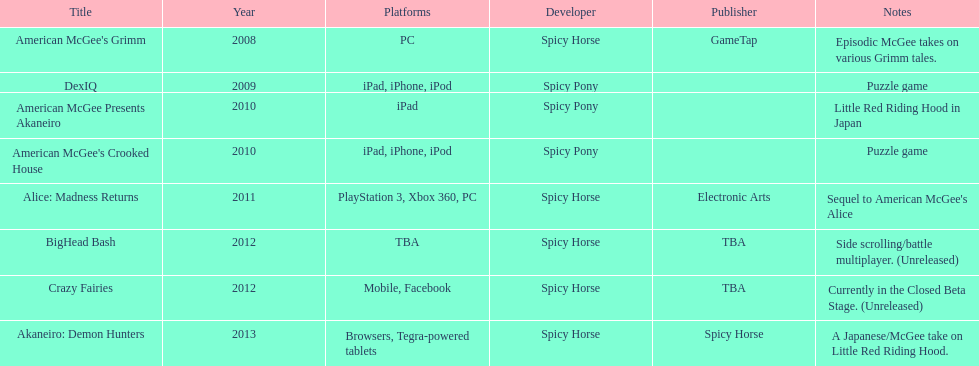Can you parse all the data within this table? {'header': ['Title', 'Year', 'Platforms', 'Developer', 'Publisher', 'Notes'], 'rows': [["American McGee's Grimm", '2008', 'PC', 'Spicy Horse', 'GameTap', 'Episodic McGee takes on various Grimm tales.'], ['DexIQ', '2009', 'iPad, iPhone, iPod', 'Spicy Pony', '', 'Puzzle game'], ['American McGee Presents Akaneiro', '2010', 'iPad', 'Spicy Pony', '', 'Little Red Riding Hood in Japan'], ["American McGee's Crooked House", '2010', 'iPad, iPhone, iPod', 'Spicy Pony', '', 'Puzzle game'], ['Alice: Madness Returns', '2011', 'PlayStation 3, Xbox 360, PC', 'Spicy Horse', 'Electronic Arts', "Sequel to American McGee's Alice"], ['BigHead Bash', '2012', 'TBA', 'Spicy Horse', 'TBA', 'Side scrolling/battle multiplayer. (Unreleased)'], ['Crazy Fairies', '2012', 'Mobile, Facebook', 'Spicy Horse', 'TBA', 'Currently in the Closed Beta Stage. (Unreleased)'], ['Akaneiro: Demon Hunters', '2013', 'Browsers, Tegra-powered tablets', 'Spicy Horse', 'Spicy Horse', 'A Japanese/McGee take on Little Red Riding Hood.']]} On how many platforms was american mcgee's grimm available? 1. 